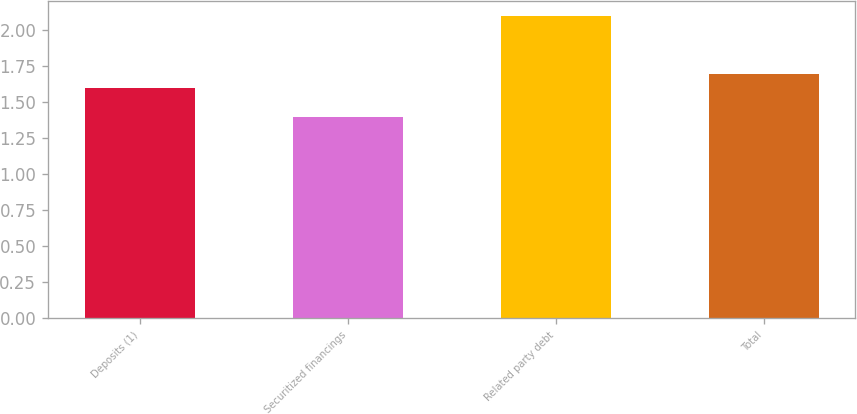Convert chart to OTSL. <chart><loc_0><loc_0><loc_500><loc_500><bar_chart><fcel>Deposits (1)<fcel>Securitized financings<fcel>Related party debt<fcel>Total<nl><fcel>1.6<fcel>1.4<fcel>2.1<fcel>1.7<nl></chart> 